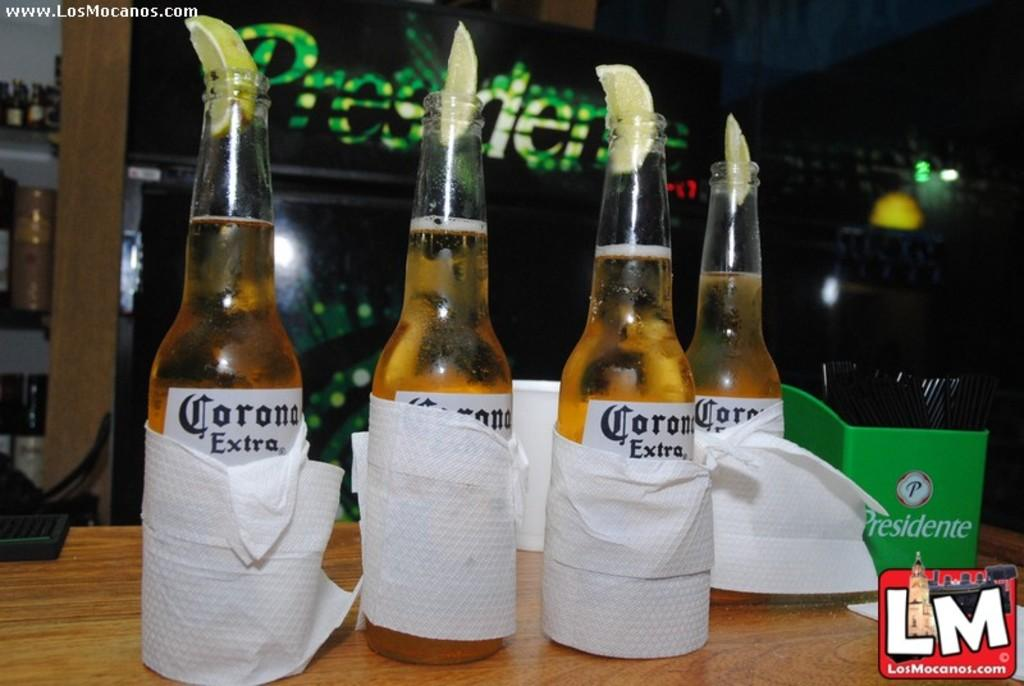<image>
Offer a succinct explanation of the picture presented. Four Coronas have limes stuffed in their tops. 